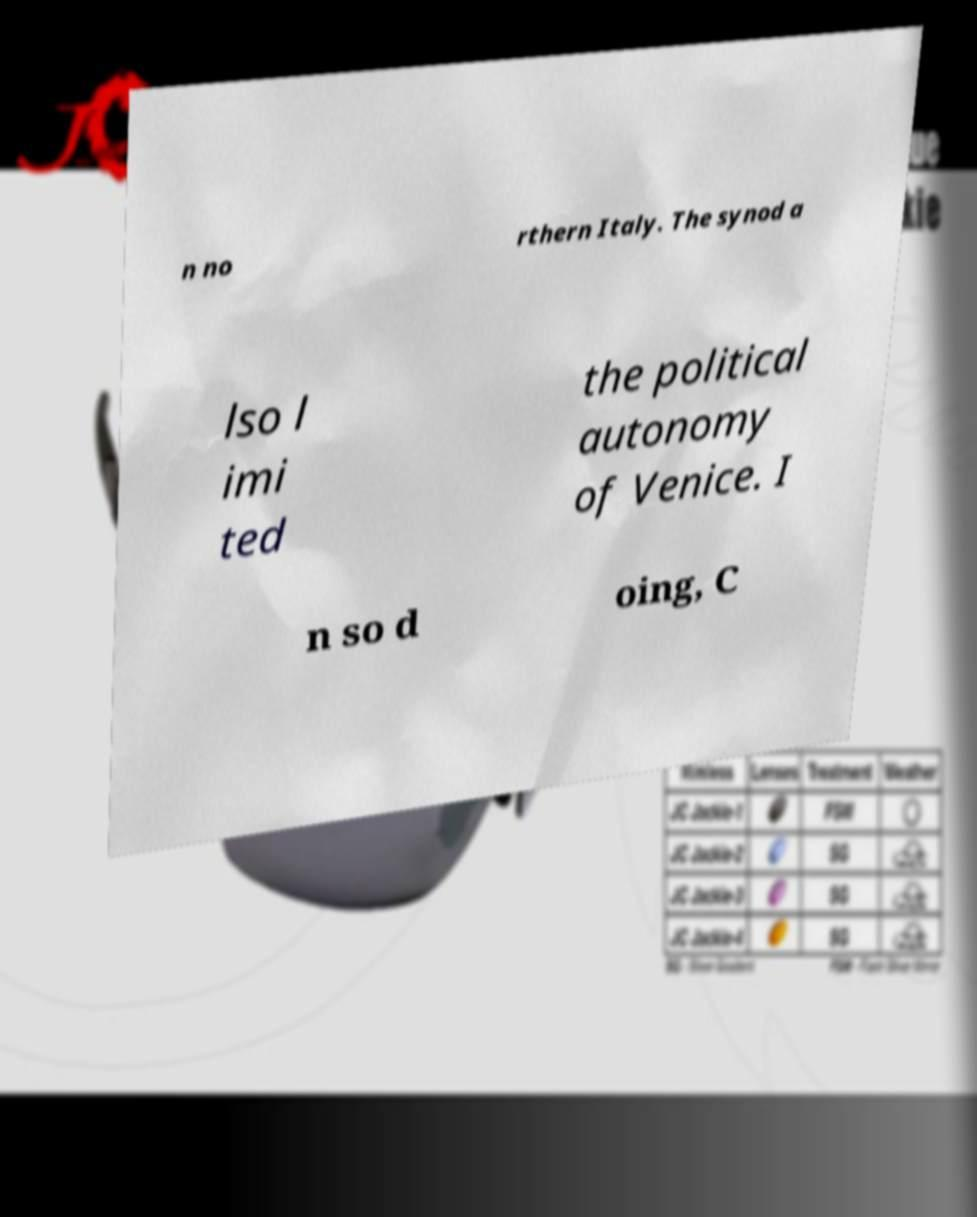What messages or text are displayed in this image? I need them in a readable, typed format. n no rthern Italy. The synod a lso l imi ted the political autonomy of Venice. I n so d oing, C 